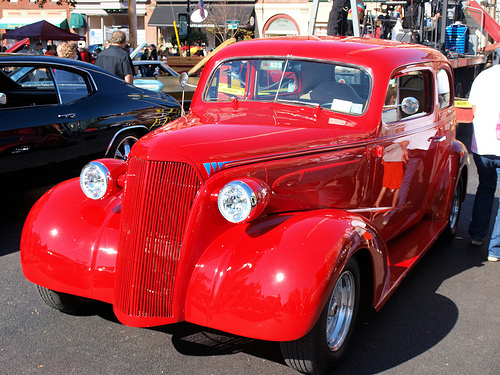<image>
Is there a car to the left of the car? Yes. From this viewpoint, the car is positioned to the left side relative to the car. 